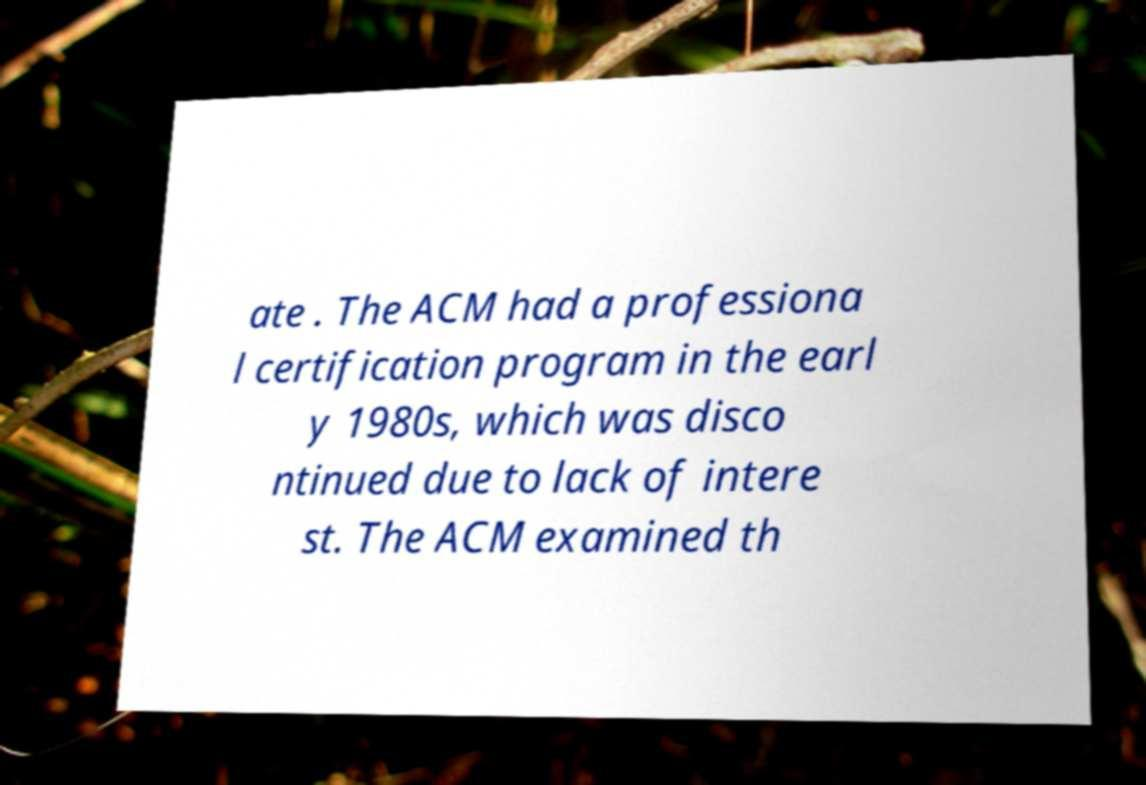What messages or text are displayed in this image? I need them in a readable, typed format. ate . The ACM had a professiona l certification program in the earl y 1980s, which was disco ntinued due to lack of intere st. The ACM examined th 